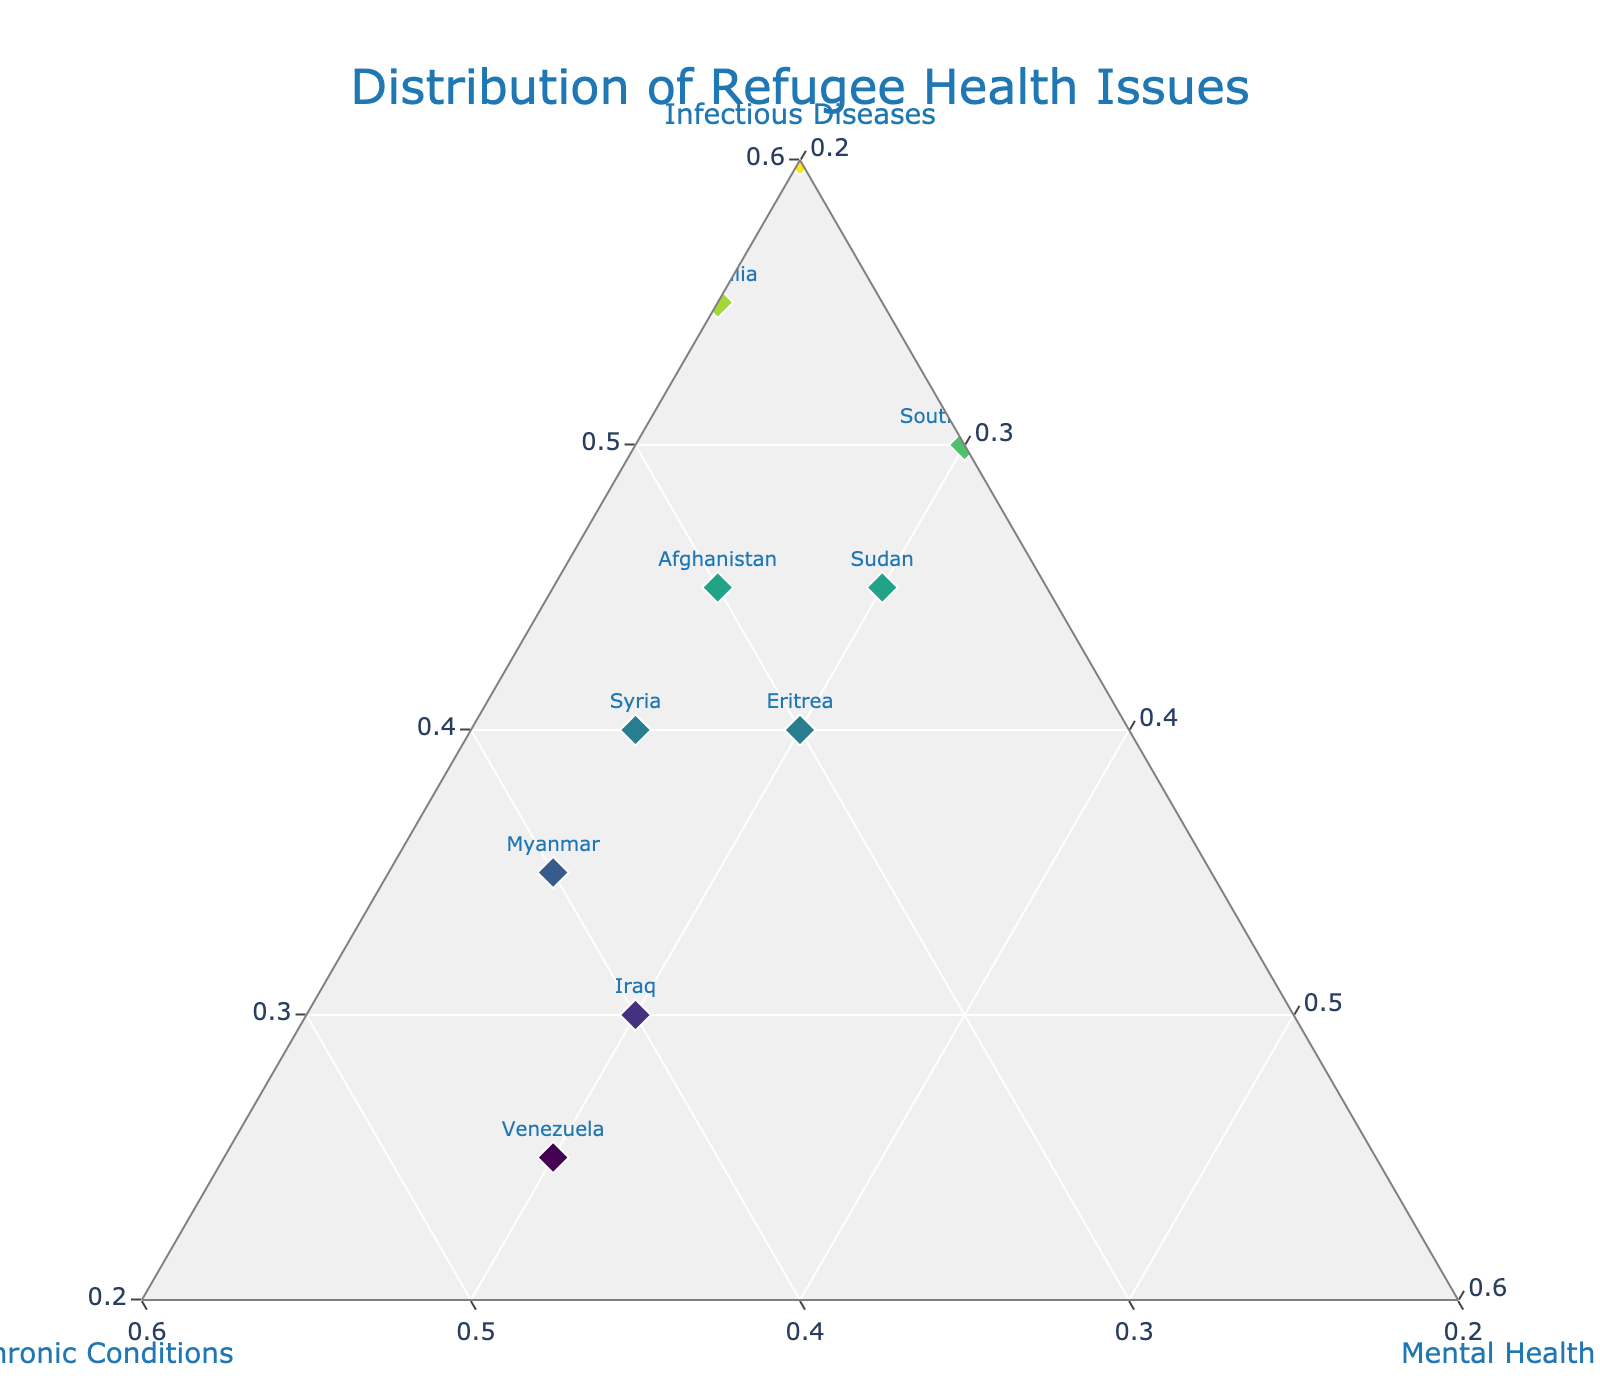What is the title of this figure? The title is typically displayed at the top of the plot, and it provides a brief description of what the figure represents.
Answer: Distribution of Refugee Health Issues How many countries are represented in this ternary plot? Count the number of labels (country names) displayed beside the markers on the plot.
Answer: 10 Which category has the highest percentage for the DRC (Democratic Republic of Congo)? Look at the position of the DRC point in the ternary plot. The nearest axis label indicates the highest percentage.
Answer: Infectious Diseases Which country has the highest proportion of mental health issues? Find the country label closest to the "Mental Health" axis, indicating a higher proportion.
Answer: South Sudan What is the sum of the proportions for chronic conditions across Syria and Iraq? Add the proportions of chronic conditions for Syria (0.35) and Iraq (0.40). 0.35 + 0.40 = 0.75
Answer: 0.75 Which country has equal proportions for chronic conditions and mental health? Identify the country point where the distances from the chronic conditions and mental health axes are equal, meaning the proportions are the same.
Answer: Iraq How do Venezuela and Myanmar compare in terms of chronic conditions? Look at the positions of both countries relative to the "Chronic Conditions" axis. Venezuela has a higher proportion if it's closer to this axis.
Answer: Venezuela has more chronic conditions Which country has the lowest proportion of infectious diseases? Look for the country farthest from the "Infectious Diseases" axis; the farther it is, the smaller the proportion.
Answer: Venezuela What is the average proportion of infectious diseases for Afghanistan and Sudan? Add the proportions for both countries (0.45 for Afghanistan and 0.45 for Sudan), then divide by 2. (0.45 + 0.45) / 2 = 0.45
Answer: 0.45 Which categories for Syria have the same proportion, and what is it? Look at the position of Syria's point. Check if any two coordinates (eg. Infectious Diseases, Chronic Conditions, Mental Health) are equal. Syria's Mental Health (0.25) and Infectious Diseases (0.25) are not the same.
Answer: None 